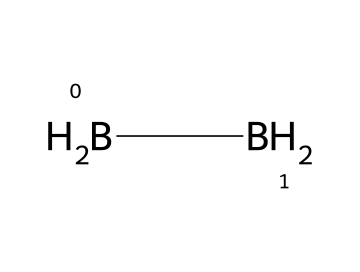What is the name of this compound? The structure is identified as diborane, which is a common borane consisting of two boron atoms and four hydrogen atoms.
Answer: diborane How many hydrogen atoms are present in diborane? The SMILES representation shows four hydrogen atoms (indicated by [H] attached to each boron atom), meaning there are 4 hydrogen atoms in total.
Answer: 4 What type of bonding exists between the boron atoms in diborane? In diborane, a three-center two-electron bond structure is present involving the interaction between two boron atoms and bridging hydrogen atoms.
Answer: three-center two-electron bond What is the total number of atoms in diborane? The molecule contains two boron atoms and four hydrogen atoms, totaling 6 atoms (2 Boron + 4 Hydrogen = 6).
Answer: 6 How many boron atoms are there in this structure? The structure indicates there are two boron atoms, as shown in the SMILES representation ([B] appears twice).
Answer: 2 What is a key property of diborane that aids its use in semiconductor manufacturing? Diborane is highly reactive and can create compounds with silicon, making it useful for doping in semiconductor applications.
Answer: reactive 